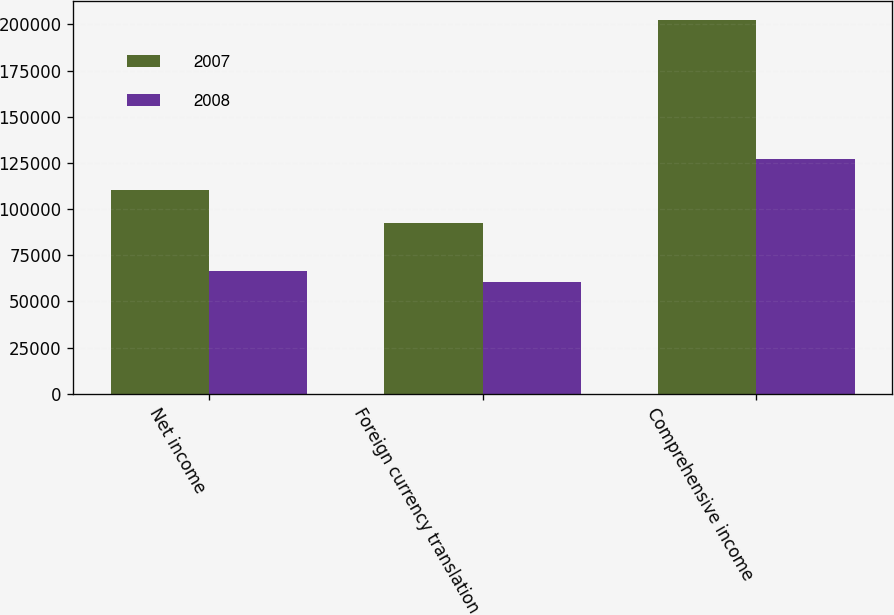<chart> <loc_0><loc_0><loc_500><loc_500><stacked_bar_chart><ecel><fcel>Net income<fcel>Foreign currency translation<fcel>Comprehensive income<nl><fcel>2007<fcel>110303<fcel>92401<fcel>202319<nl><fcel>2008<fcel>66302<fcel>60619<fcel>126921<nl></chart> 